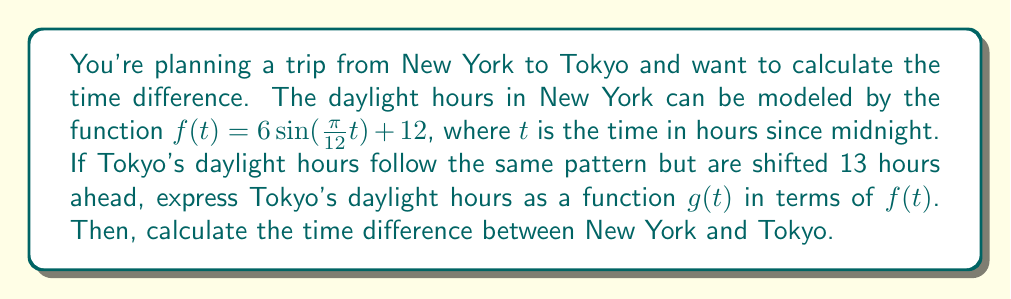Provide a solution to this math problem. 1) First, we need to understand that Tokyo's daylight pattern is the same as New York's, but shifted 13 hours ahead. This means we need to apply a horizontal shift to $f(t)$.

2) For a horizontal shift of $h$ units to the left, we replace $t$ with $(t+h)$ in the original function. In this case, $h=13$ because Tokyo is 13 hours ahead.

3) Therefore, Tokyo's daylight function $g(t)$ can be expressed as:

   $g(t) = f(t+13)$

4) This means that for any given time $t$ in Tokyo, the daylight hours will be the same as they were in New York 13 hours earlier.

5) The time difference between two locations is equal to the horizontal shift required to transform one location's time function into the other's.

6) In this case, the horizontal shift is 13 hours to the left, which means Tokyo is 13 hours ahead of New York.
Answer: $g(t) = f(t+13)$; 13 hours 